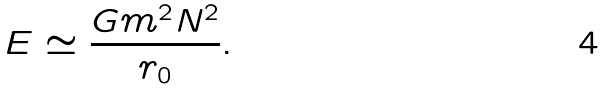Convert formula to latex. <formula><loc_0><loc_0><loc_500><loc_500>E \simeq \frac { G m ^ { 2 } N ^ { 2 } } { r _ { 0 } } .</formula> 